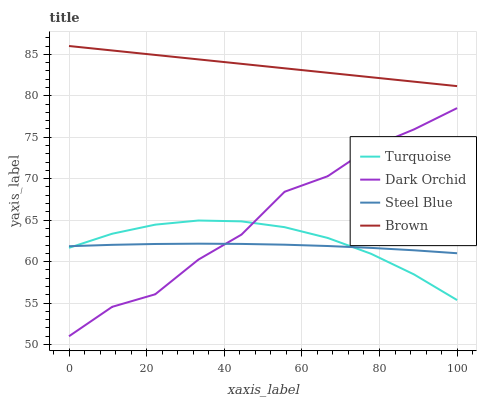Does Steel Blue have the minimum area under the curve?
Answer yes or no. Yes. Does Brown have the maximum area under the curve?
Answer yes or no. Yes. Does Turquoise have the minimum area under the curve?
Answer yes or no. No. Does Turquoise have the maximum area under the curve?
Answer yes or no. No. Is Brown the smoothest?
Answer yes or no. Yes. Is Dark Orchid the roughest?
Answer yes or no. Yes. Is Turquoise the smoothest?
Answer yes or no. No. Is Turquoise the roughest?
Answer yes or no. No. Does Turquoise have the lowest value?
Answer yes or no. No. Does Brown have the highest value?
Answer yes or no. Yes. Does Turquoise have the highest value?
Answer yes or no. No. Is Turquoise less than Brown?
Answer yes or no. Yes. Is Brown greater than Steel Blue?
Answer yes or no. Yes. Does Dark Orchid intersect Turquoise?
Answer yes or no. Yes. Is Dark Orchid less than Turquoise?
Answer yes or no. No. Is Dark Orchid greater than Turquoise?
Answer yes or no. No. Does Turquoise intersect Brown?
Answer yes or no. No. 